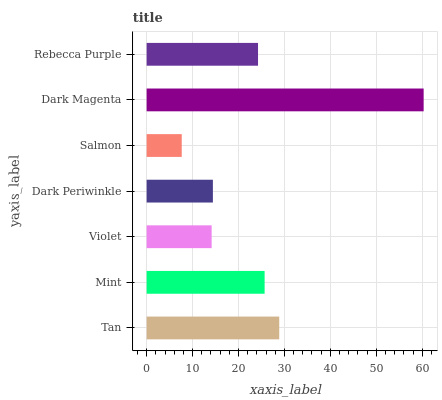Is Salmon the minimum?
Answer yes or no. Yes. Is Dark Magenta the maximum?
Answer yes or no. Yes. Is Mint the minimum?
Answer yes or no. No. Is Mint the maximum?
Answer yes or no. No. Is Tan greater than Mint?
Answer yes or no. Yes. Is Mint less than Tan?
Answer yes or no. Yes. Is Mint greater than Tan?
Answer yes or no. No. Is Tan less than Mint?
Answer yes or no. No. Is Rebecca Purple the high median?
Answer yes or no. Yes. Is Rebecca Purple the low median?
Answer yes or no. Yes. Is Salmon the high median?
Answer yes or no. No. Is Dark Magenta the low median?
Answer yes or no. No. 